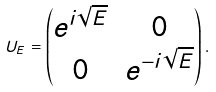<formula> <loc_0><loc_0><loc_500><loc_500>U _ { E } = \begin{pmatrix} e ^ { i \sqrt { E } } & 0 \\ 0 & e ^ { - i \sqrt { E } } \end{pmatrix} .</formula> 